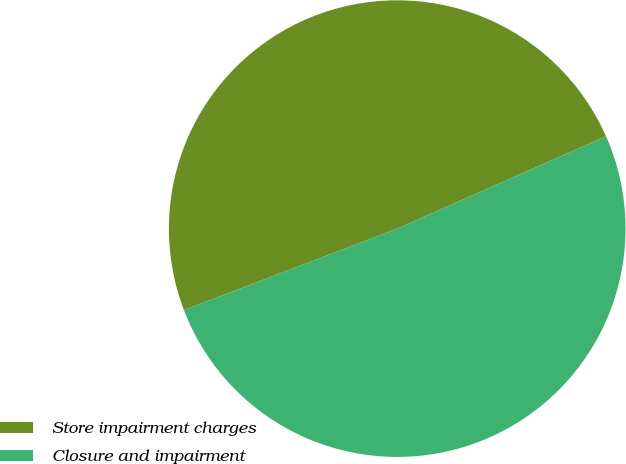<chart> <loc_0><loc_0><loc_500><loc_500><pie_chart><fcel>Store impairment charges<fcel>Closure and impairment<nl><fcel>49.18%<fcel>50.82%<nl></chart> 